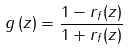<formula> <loc_0><loc_0><loc_500><loc_500>g \left ( z \right ) = \frac { 1 - r _ { f } ( z ) } { 1 + r _ { f } ( z ) }</formula> 